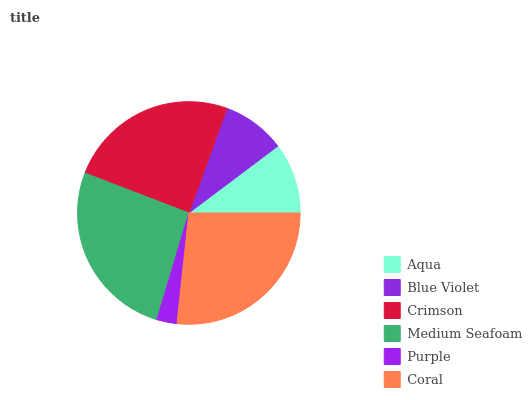Is Purple the minimum?
Answer yes or no. Yes. Is Coral the maximum?
Answer yes or no. Yes. Is Blue Violet the minimum?
Answer yes or no. No. Is Blue Violet the maximum?
Answer yes or no. No. Is Aqua greater than Blue Violet?
Answer yes or no. Yes. Is Blue Violet less than Aqua?
Answer yes or no. Yes. Is Blue Violet greater than Aqua?
Answer yes or no. No. Is Aqua less than Blue Violet?
Answer yes or no. No. Is Crimson the high median?
Answer yes or no. Yes. Is Aqua the low median?
Answer yes or no. Yes. Is Aqua the high median?
Answer yes or no. No. Is Crimson the low median?
Answer yes or no. No. 